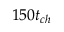Convert formula to latex. <formula><loc_0><loc_0><loc_500><loc_500>1 5 0 t _ { c h }</formula> 